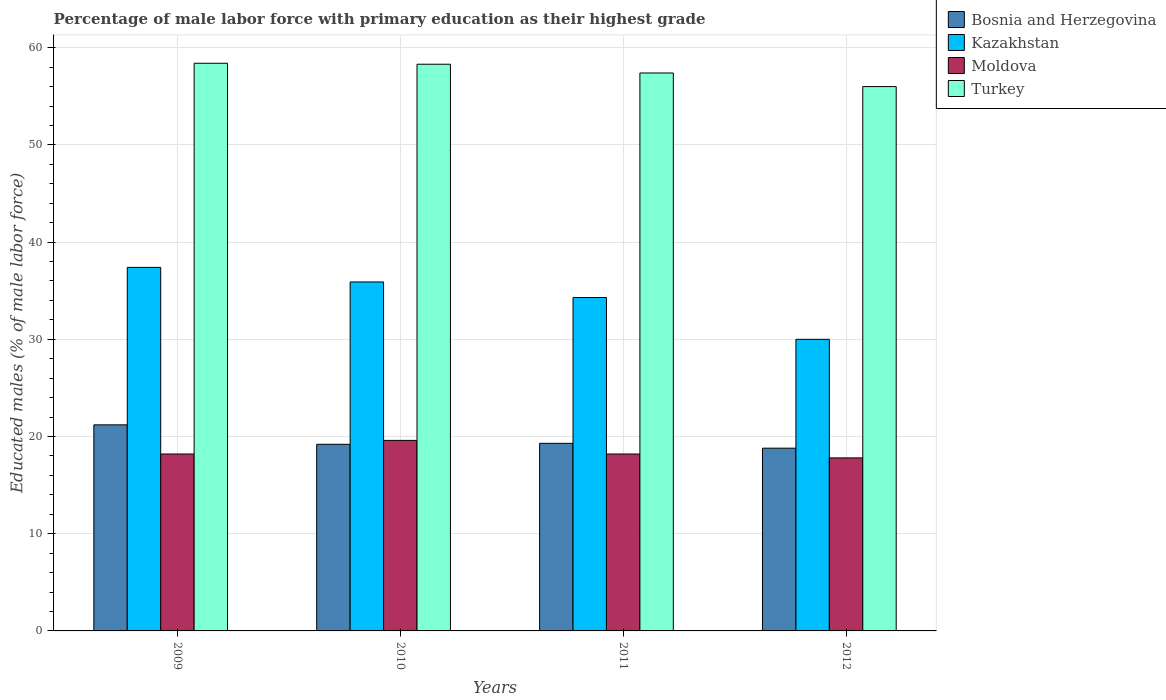How many groups of bars are there?
Your answer should be compact. 4. Are the number of bars per tick equal to the number of legend labels?
Your response must be concise. Yes. Are the number of bars on each tick of the X-axis equal?
Give a very brief answer. Yes. How many bars are there on the 1st tick from the left?
Make the answer very short. 4. How many bars are there on the 2nd tick from the right?
Ensure brevity in your answer.  4. In how many cases, is the number of bars for a given year not equal to the number of legend labels?
Your answer should be compact. 0. What is the percentage of male labor force with primary education in Moldova in 2011?
Make the answer very short. 18.2. Across all years, what is the maximum percentage of male labor force with primary education in Moldova?
Provide a short and direct response. 19.6. In which year was the percentage of male labor force with primary education in Kazakhstan maximum?
Ensure brevity in your answer.  2009. In which year was the percentage of male labor force with primary education in Moldova minimum?
Offer a very short reply. 2012. What is the total percentage of male labor force with primary education in Turkey in the graph?
Give a very brief answer. 230.1. What is the difference between the percentage of male labor force with primary education in Turkey in 2011 and that in 2012?
Offer a very short reply. 1.4. What is the average percentage of male labor force with primary education in Kazakhstan per year?
Offer a terse response. 34.4. In the year 2011, what is the difference between the percentage of male labor force with primary education in Moldova and percentage of male labor force with primary education in Kazakhstan?
Your response must be concise. -16.1. In how many years, is the percentage of male labor force with primary education in Kazakhstan greater than 32 %?
Your answer should be compact. 3. What is the ratio of the percentage of male labor force with primary education in Moldova in 2009 to that in 2012?
Your answer should be compact. 1.02. Is the percentage of male labor force with primary education in Bosnia and Herzegovina in 2009 less than that in 2012?
Provide a succinct answer. No. What is the difference between the highest and the second highest percentage of male labor force with primary education in Moldova?
Give a very brief answer. 1.4. What is the difference between the highest and the lowest percentage of male labor force with primary education in Turkey?
Offer a very short reply. 2.4. Is the sum of the percentage of male labor force with primary education in Moldova in 2009 and 2012 greater than the maximum percentage of male labor force with primary education in Kazakhstan across all years?
Make the answer very short. No. Is it the case that in every year, the sum of the percentage of male labor force with primary education in Moldova and percentage of male labor force with primary education in Bosnia and Herzegovina is greater than the sum of percentage of male labor force with primary education in Kazakhstan and percentage of male labor force with primary education in Turkey?
Keep it short and to the point. No. What does the 2nd bar from the left in 2011 represents?
Offer a very short reply. Kazakhstan. What does the 3rd bar from the right in 2009 represents?
Offer a very short reply. Kazakhstan. Is it the case that in every year, the sum of the percentage of male labor force with primary education in Turkey and percentage of male labor force with primary education in Bosnia and Herzegovina is greater than the percentage of male labor force with primary education in Kazakhstan?
Your response must be concise. Yes. Where does the legend appear in the graph?
Provide a short and direct response. Top right. How are the legend labels stacked?
Offer a very short reply. Vertical. What is the title of the graph?
Provide a succinct answer. Percentage of male labor force with primary education as their highest grade. What is the label or title of the Y-axis?
Make the answer very short. Educated males (% of male labor force). What is the Educated males (% of male labor force) in Bosnia and Herzegovina in 2009?
Ensure brevity in your answer.  21.2. What is the Educated males (% of male labor force) of Kazakhstan in 2009?
Ensure brevity in your answer.  37.4. What is the Educated males (% of male labor force) of Moldova in 2009?
Your response must be concise. 18.2. What is the Educated males (% of male labor force) in Turkey in 2009?
Make the answer very short. 58.4. What is the Educated males (% of male labor force) of Bosnia and Herzegovina in 2010?
Provide a short and direct response. 19.2. What is the Educated males (% of male labor force) in Kazakhstan in 2010?
Your answer should be very brief. 35.9. What is the Educated males (% of male labor force) of Moldova in 2010?
Offer a very short reply. 19.6. What is the Educated males (% of male labor force) in Turkey in 2010?
Give a very brief answer. 58.3. What is the Educated males (% of male labor force) in Bosnia and Herzegovina in 2011?
Your response must be concise. 19.3. What is the Educated males (% of male labor force) in Kazakhstan in 2011?
Offer a very short reply. 34.3. What is the Educated males (% of male labor force) in Moldova in 2011?
Offer a terse response. 18.2. What is the Educated males (% of male labor force) of Turkey in 2011?
Ensure brevity in your answer.  57.4. What is the Educated males (% of male labor force) of Bosnia and Herzegovina in 2012?
Offer a terse response. 18.8. What is the Educated males (% of male labor force) of Moldova in 2012?
Ensure brevity in your answer.  17.8. What is the Educated males (% of male labor force) of Turkey in 2012?
Ensure brevity in your answer.  56. Across all years, what is the maximum Educated males (% of male labor force) of Bosnia and Herzegovina?
Offer a very short reply. 21.2. Across all years, what is the maximum Educated males (% of male labor force) in Kazakhstan?
Make the answer very short. 37.4. Across all years, what is the maximum Educated males (% of male labor force) of Moldova?
Provide a succinct answer. 19.6. Across all years, what is the maximum Educated males (% of male labor force) of Turkey?
Ensure brevity in your answer.  58.4. Across all years, what is the minimum Educated males (% of male labor force) of Bosnia and Herzegovina?
Your answer should be compact. 18.8. Across all years, what is the minimum Educated males (% of male labor force) of Moldova?
Your answer should be compact. 17.8. Across all years, what is the minimum Educated males (% of male labor force) of Turkey?
Make the answer very short. 56. What is the total Educated males (% of male labor force) in Bosnia and Herzegovina in the graph?
Your response must be concise. 78.5. What is the total Educated males (% of male labor force) of Kazakhstan in the graph?
Keep it short and to the point. 137.6. What is the total Educated males (% of male labor force) in Moldova in the graph?
Provide a succinct answer. 73.8. What is the total Educated males (% of male labor force) of Turkey in the graph?
Your answer should be very brief. 230.1. What is the difference between the Educated males (% of male labor force) of Kazakhstan in 2009 and that in 2010?
Offer a terse response. 1.5. What is the difference between the Educated males (% of male labor force) of Turkey in 2009 and that in 2010?
Offer a very short reply. 0.1. What is the difference between the Educated males (% of male labor force) of Bosnia and Herzegovina in 2009 and that in 2011?
Your answer should be compact. 1.9. What is the difference between the Educated males (% of male labor force) of Bosnia and Herzegovina in 2009 and that in 2012?
Provide a succinct answer. 2.4. What is the difference between the Educated males (% of male labor force) in Kazakhstan in 2009 and that in 2012?
Ensure brevity in your answer.  7.4. What is the difference between the Educated males (% of male labor force) in Moldova in 2009 and that in 2012?
Make the answer very short. 0.4. What is the difference between the Educated males (% of male labor force) in Bosnia and Herzegovina in 2010 and that in 2011?
Offer a terse response. -0.1. What is the difference between the Educated males (% of male labor force) in Bosnia and Herzegovina in 2010 and that in 2012?
Your answer should be compact. 0.4. What is the difference between the Educated males (% of male labor force) in Kazakhstan in 2010 and that in 2012?
Provide a short and direct response. 5.9. What is the difference between the Educated males (% of male labor force) in Moldova in 2010 and that in 2012?
Your response must be concise. 1.8. What is the difference between the Educated males (% of male labor force) in Turkey in 2010 and that in 2012?
Provide a succinct answer. 2.3. What is the difference between the Educated males (% of male labor force) in Bosnia and Herzegovina in 2011 and that in 2012?
Your answer should be very brief. 0.5. What is the difference between the Educated males (% of male labor force) in Bosnia and Herzegovina in 2009 and the Educated males (% of male labor force) in Kazakhstan in 2010?
Give a very brief answer. -14.7. What is the difference between the Educated males (% of male labor force) in Bosnia and Herzegovina in 2009 and the Educated males (% of male labor force) in Turkey in 2010?
Ensure brevity in your answer.  -37.1. What is the difference between the Educated males (% of male labor force) in Kazakhstan in 2009 and the Educated males (% of male labor force) in Moldova in 2010?
Provide a short and direct response. 17.8. What is the difference between the Educated males (% of male labor force) of Kazakhstan in 2009 and the Educated males (% of male labor force) of Turkey in 2010?
Offer a terse response. -20.9. What is the difference between the Educated males (% of male labor force) in Moldova in 2009 and the Educated males (% of male labor force) in Turkey in 2010?
Make the answer very short. -40.1. What is the difference between the Educated males (% of male labor force) of Bosnia and Herzegovina in 2009 and the Educated males (% of male labor force) of Turkey in 2011?
Ensure brevity in your answer.  -36.2. What is the difference between the Educated males (% of male labor force) of Kazakhstan in 2009 and the Educated males (% of male labor force) of Turkey in 2011?
Provide a succinct answer. -20. What is the difference between the Educated males (% of male labor force) of Moldova in 2009 and the Educated males (% of male labor force) of Turkey in 2011?
Provide a succinct answer. -39.2. What is the difference between the Educated males (% of male labor force) of Bosnia and Herzegovina in 2009 and the Educated males (% of male labor force) of Turkey in 2012?
Your answer should be compact. -34.8. What is the difference between the Educated males (% of male labor force) in Kazakhstan in 2009 and the Educated males (% of male labor force) in Moldova in 2012?
Make the answer very short. 19.6. What is the difference between the Educated males (% of male labor force) of Kazakhstan in 2009 and the Educated males (% of male labor force) of Turkey in 2012?
Offer a very short reply. -18.6. What is the difference between the Educated males (% of male labor force) of Moldova in 2009 and the Educated males (% of male labor force) of Turkey in 2012?
Provide a succinct answer. -37.8. What is the difference between the Educated males (% of male labor force) in Bosnia and Herzegovina in 2010 and the Educated males (% of male labor force) in Kazakhstan in 2011?
Your response must be concise. -15.1. What is the difference between the Educated males (% of male labor force) of Bosnia and Herzegovina in 2010 and the Educated males (% of male labor force) of Moldova in 2011?
Make the answer very short. 1. What is the difference between the Educated males (% of male labor force) in Bosnia and Herzegovina in 2010 and the Educated males (% of male labor force) in Turkey in 2011?
Ensure brevity in your answer.  -38.2. What is the difference between the Educated males (% of male labor force) of Kazakhstan in 2010 and the Educated males (% of male labor force) of Moldova in 2011?
Your answer should be compact. 17.7. What is the difference between the Educated males (% of male labor force) of Kazakhstan in 2010 and the Educated males (% of male labor force) of Turkey in 2011?
Give a very brief answer. -21.5. What is the difference between the Educated males (% of male labor force) in Moldova in 2010 and the Educated males (% of male labor force) in Turkey in 2011?
Keep it short and to the point. -37.8. What is the difference between the Educated males (% of male labor force) of Bosnia and Herzegovina in 2010 and the Educated males (% of male labor force) of Turkey in 2012?
Your answer should be compact. -36.8. What is the difference between the Educated males (% of male labor force) in Kazakhstan in 2010 and the Educated males (% of male labor force) in Moldova in 2012?
Your response must be concise. 18.1. What is the difference between the Educated males (% of male labor force) in Kazakhstan in 2010 and the Educated males (% of male labor force) in Turkey in 2012?
Your answer should be compact. -20.1. What is the difference between the Educated males (% of male labor force) in Moldova in 2010 and the Educated males (% of male labor force) in Turkey in 2012?
Provide a short and direct response. -36.4. What is the difference between the Educated males (% of male labor force) in Bosnia and Herzegovina in 2011 and the Educated males (% of male labor force) in Kazakhstan in 2012?
Make the answer very short. -10.7. What is the difference between the Educated males (% of male labor force) of Bosnia and Herzegovina in 2011 and the Educated males (% of male labor force) of Turkey in 2012?
Offer a terse response. -36.7. What is the difference between the Educated males (% of male labor force) of Kazakhstan in 2011 and the Educated males (% of male labor force) of Turkey in 2012?
Make the answer very short. -21.7. What is the difference between the Educated males (% of male labor force) in Moldova in 2011 and the Educated males (% of male labor force) in Turkey in 2012?
Your response must be concise. -37.8. What is the average Educated males (% of male labor force) of Bosnia and Herzegovina per year?
Your answer should be compact. 19.62. What is the average Educated males (% of male labor force) in Kazakhstan per year?
Ensure brevity in your answer.  34.4. What is the average Educated males (% of male labor force) in Moldova per year?
Provide a succinct answer. 18.45. What is the average Educated males (% of male labor force) in Turkey per year?
Offer a terse response. 57.52. In the year 2009, what is the difference between the Educated males (% of male labor force) in Bosnia and Herzegovina and Educated males (% of male labor force) in Kazakhstan?
Make the answer very short. -16.2. In the year 2009, what is the difference between the Educated males (% of male labor force) of Bosnia and Herzegovina and Educated males (% of male labor force) of Moldova?
Give a very brief answer. 3. In the year 2009, what is the difference between the Educated males (% of male labor force) in Bosnia and Herzegovina and Educated males (% of male labor force) in Turkey?
Your response must be concise. -37.2. In the year 2009, what is the difference between the Educated males (% of male labor force) in Kazakhstan and Educated males (% of male labor force) in Moldova?
Keep it short and to the point. 19.2. In the year 2009, what is the difference between the Educated males (% of male labor force) of Moldova and Educated males (% of male labor force) of Turkey?
Provide a short and direct response. -40.2. In the year 2010, what is the difference between the Educated males (% of male labor force) of Bosnia and Herzegovina and Educated males (% of male labor force) of Kazakhstan?
Your answer should be compact. -16.7. In the year 2010, what is the difference between the Educated males (% of male labor force) of Bosnia and Herzegovina and Educated males (% of male labor force) of Turkey?
Make the answer very short. -39.1. In the year 2010, what is the difference between the Educated males (% of male labor force) in Kazakhstan and Educated males (% of male labor force) in Turkey?
Offer a very short reply. -22.4. In the year 2010, what is the difference between the Educated males (% of male labor force) of Moldova and Educated males (% of male labor force) of Turkey?
Offer a very short reply. -38.7. In the year 2011, what is the difference between the Educated males (% of male labor force) of Bosnia and Herzegovina and Educated males (% of male labor force) of Kazakhstan?
Offer a terse response. -15. In the year 2011, what is the difference between the Educated males (% of male labor force) of Bosnia and Herzegovina and Educated males (% of male labor force) of Moldova?
Your answer should be compact. 1.1. In the year 2011, what is the difference between the Educated males (% of male labor force) in Bosnia and Herzegovina and Educated males (% of male labor force) in Turkey?
Make the answer very short. -38.1. In the year 2011, what is the difference between the Educated males (% of male labor force) of Kazakhstan and Educated males (% of male labor force) of Turkey?
Offer a terse response. -23.1. In the year 2011, what is the difference between the Educated males (% of male labor force) in Moldova and Educated males (% of male labor force) in Turkey?
Ensure brevity in your answer.  -39.2. In the year 2012, what is the difference between the Educated males (% of male labor force) of Bosnia and Herzegovina and Educated males (% of male labor force) of Kazakhstan?
Ensure brevity in your answer.  -11.2. In the year 2012, what is the difference between the Educated males (% of male labor force) of Bosnia and Herzegovina and Educated males (% of male labor force) of Moldova?
Your answer should be compact. 1. In the year 2012, what is the difference between the Educated males (% of male labor force) of Bosnia and Herzegovina and Educated males (% of male labor force) of Turkey?
Provide a short and direct response. -37.2. In the year 2012, what is the difference between the Educated males (% of male labor force) in Moldova and Educated males (% of male labor force) in Turkey?
Offer a terse response. -38.2. What is the ratio of the Educated males (% of male labor force) in Bosnia and Herzegovina in 2009 to that in 2010?
Provide a short and direct response. 1.1. What is the ratio of the Educated males (% of male labor force) of Kazakhstan in 2009 to that in 2010?
Your answer should be very brief. 1.04. What is the ratio of the Educated males (% of male labor force) in Moldova in 2009 to that in 2010?
Make the answer very short. 0.93. What is the ratio of the Educated males (% of male labor force) in Turkey in 2009 to that in 2010?
Provide a short and direct response. 1. What is the ratio of the Educated males (% of male labor force) in Bosnia and Herzegovina in 2009 to that in 2011?
Keep it short and to the point. 1.1. What is the ratio of the Educated males (% of male labor force) of Kazakhstan in 2009 to that in 2011?
Keep it short and to the point. 1.09. What is the ratio of the Educated males (% of male labor force) in Moldova in 2009 to that in 2011?
Offer a very short reply. 1. What is the ratio of the Educated males (% of male labor force) of Turkey in 2009 to that in 2011?
Your response must be concise. 1.02. What is the ratio of the Educated males (% of male labor force) of Bosnia and Herzegovina in 2009 to that in 2012?
Provide a succinct answer. 1.13. What is the ratio of the Educated males (% of male labor force) of Kazakhstan in 2009 to that in 2012?
Offer a very short reply. 1.25. What is the ratio of the Educated males (% of male labor force) in Moldova in 2009 to that in 2012?
Make the answer very short. 1.02. What is the ratio of the Educated males (% of male labor force) in Turkey in 2009 to that in 2012?
Offer a very short reply. 1.04. What is the ratio of the Educated males (% of male labor force) in Kazakhstan in 2010 to that in 2011?
Make the answer very short. 1.05. What is the ratio of the Educated males (% of male labor force) in Turkey in 2010 to that in 2011?
Your answer should be compact. 1.02. What is the ratio of the Educated males (% of male labor force) of Bosnia and Herzegovina in 2010 to that in 2012?
Make the answer very short. 1.02. What is the ratio of the Educated males (% of male labor force) of Kazakhstan in 2010 to that in 2012?
Your answer should be very brief. 1.2. What is the ratio of the Educated males (% of male labor force) in Moldova in 2010 to that in 2012?
Offer a terse response. 1.1. What is the ratio of the Educated males (% of male labor force) of Turkey in 2010 to that in 2012?
Your response must be concise. 1.04. What is the ratio of the Educated males (% of male labor force) of Bosnia and Herzegovina in 2011 to that in 2012?
Keep it short and to the point. 1.03. What is the ratio of the Educated males (% of male labor force) in Kazakhstan in 2011 to that in 2012?
Make the answer very short. 1.14. What is the ratio of the Educated males (% of male labor force) in Moldova in 2011 to that in 2012?
Provide a short and direct response. 1.02. What is the ratio of the Educated males (% of male labor force) in Turkey in 2011 to that in 2012?
Give a very brief answer. 1.02. What is the difference between the highest and the second highest Educated males (% of male labor force) of Kazakhstan?
Your response must be concise. 1.5. What is the difference between the highest and the second highest Educated males (% of male labor force) of Moldova?
Provide a short and direct response. 1.4. What is the difference between the highest and the second highest Educated males (% of male labor force) of Turkey?
Provide a succinct answer. 0.1. What is the difference between the highest and the lowest Educated males (% of male labor force) of Bosnia and Herzegovina?
Offer a terse response. 2.4. What is the difference between the highest and the lowest Educated males (% of male labor force) of Moldova?
Your response must be concise. 1.8. 